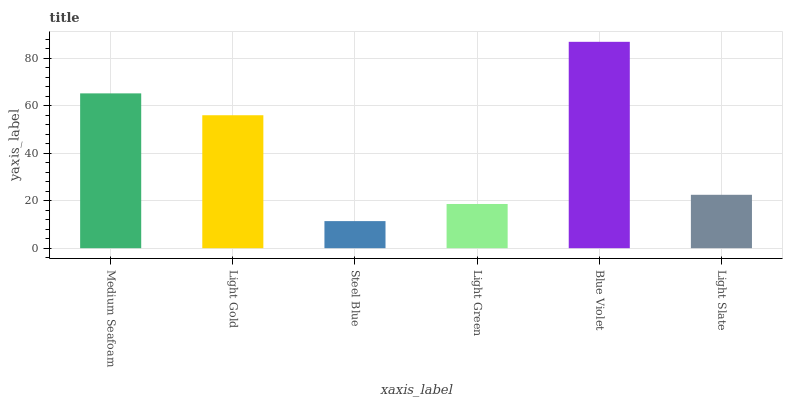Is Steel Blue the minimum?
Answer yes or no. Yes. Is Blue Violet the maximum?
Answer yes or no. Yes. Is Light Gold the minimum?
Answer yes or no. No. Is Light Gold the maximum?
Answer yes or no. No. Is Medium Seafoam greater than Light Gold?
Answer yes or no. Yes. Is Light Gold less than Medium Seafoam?
Answer yes or no. Yes. Is Light Gold greater than Medium Seafoam?
Answer yes or no. No. Is Medium Seafoam less than Light Gold?
Answer yes or no. No. Is Light Gold the high median?
Answer yes or no. Yes. Is Light Slate the low median?
Answer yes or no. Yes. Is Blue Violet the high median?
Answer yes or no. No. Is Medium Seafoam the low median?
Answer yes or no. No. 